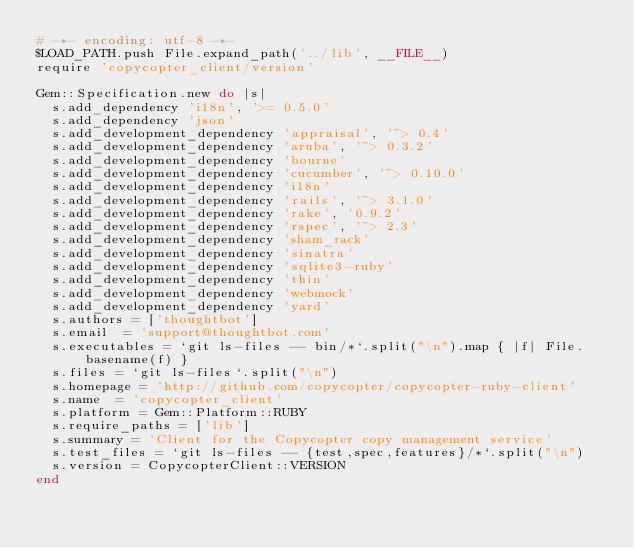Convert code to text. <code><loc_0><loc_0><loc_500><loc_500><_Ruby_># -*- encoding: utf-8 -*-
$LOAD_PATH.push File.expand_path('../lib', __FILE__)
require 'copycopter_client/version'

Gem::Specification.new do |s|
  s.add_dependency 'i18n', '>= 0.5.0'
  s.add_dependency 'json'
  s.add_development_dependency 'appraisal', '~> 0.4'
  s.add_development_dependency 'aruba', '~> 0.3.2'
  s.add_development_dependency 'bourne'
  s.add_development_dependency 'cucumber', '~> 0.10.0'
  s.add_development_dependency 'i18n'
  s.add_development_dependency 'rails', '~> 3.1.0'
  s.add_development_dependency 'rake', '0.9.2'
  s.add_development_dependency 'rspec', '~> 2.3'
  s.add_development_dependency 'sham_rack'
  s.add_development_dependency 'sinatra'
  s.add_development_dependency 'sqlite3-ruby'
  s.add_development_dependency 'thin'
  s.add_development_dependency 'webmock'
  s.add_development_dependency 'yard'
  s.authors = ['thoughtbot']
  s.email  = 'support@thoughtbot.com'
  s.executables = `git ls-files -- bin/*`.split("\n").map { |f| File.basename(f) }
  s.files = `git ls-files`.split("\n")
  s.homepage = 'http://github.com/copycopter/copycopter-ruby-client'
  s.name  = 'copycopter_client'
  s.platform = Gem::Platform::RUBY
  s.require_paths = ['lib']
  s.summary = 'Client for the Copycopter copy management service'
  s.test_files = `git ls-files -- {test,spec,features}/*`.split("\n")
  s.version = CopycopterClient::VERSION
end
</code> 